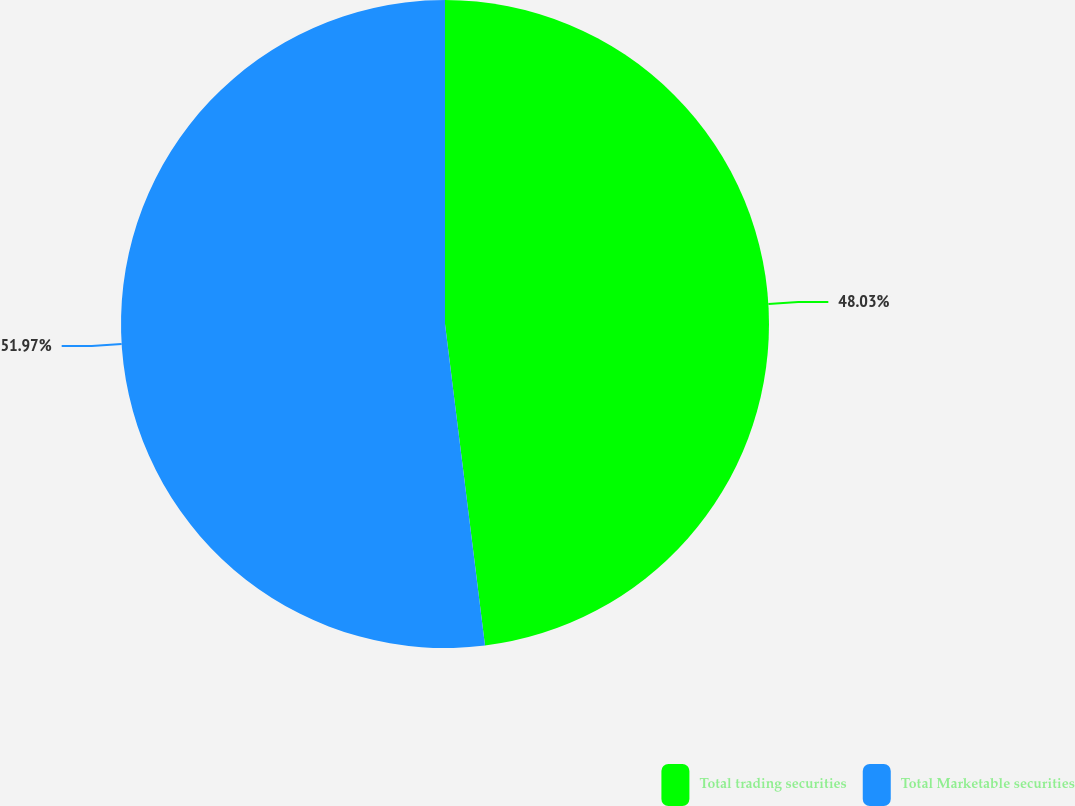Convert chart to OTSL. <chart><loc_0><loc_0><loc_500><loc_500><pie_chart><fcel>Total trading securities<fcel>Total Marketable securities<nl><fcel>48.03%<fcel>51.97%<nl></chart> 